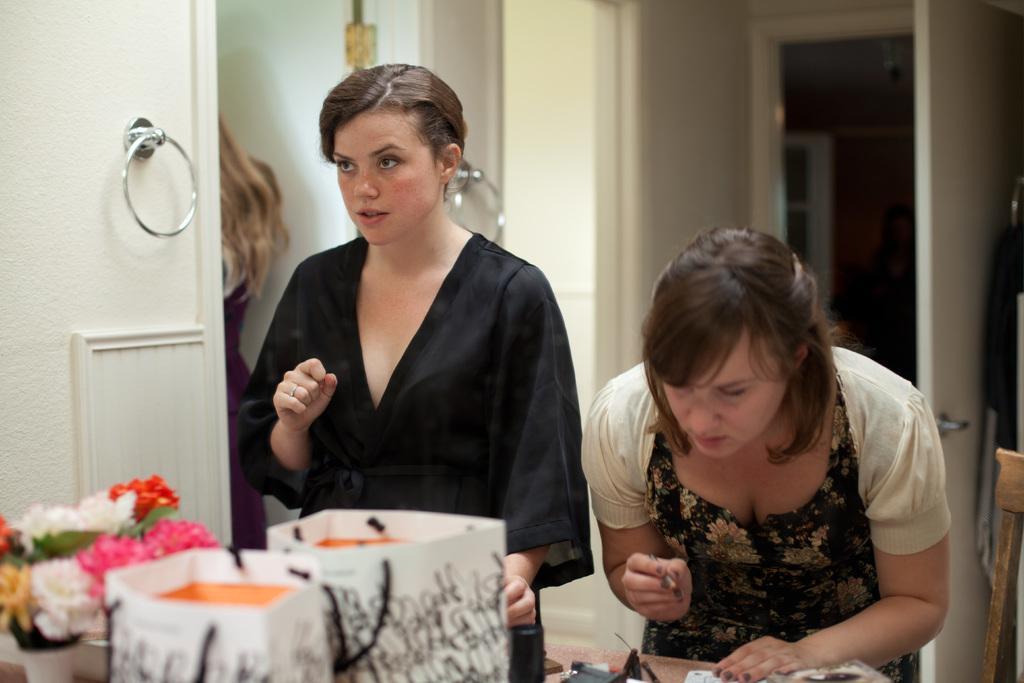Can you describe this image briefly? On the background we can see door, wall. Here we can see two women standing in front of a table and on the table we can see carry bags, flower pots. 